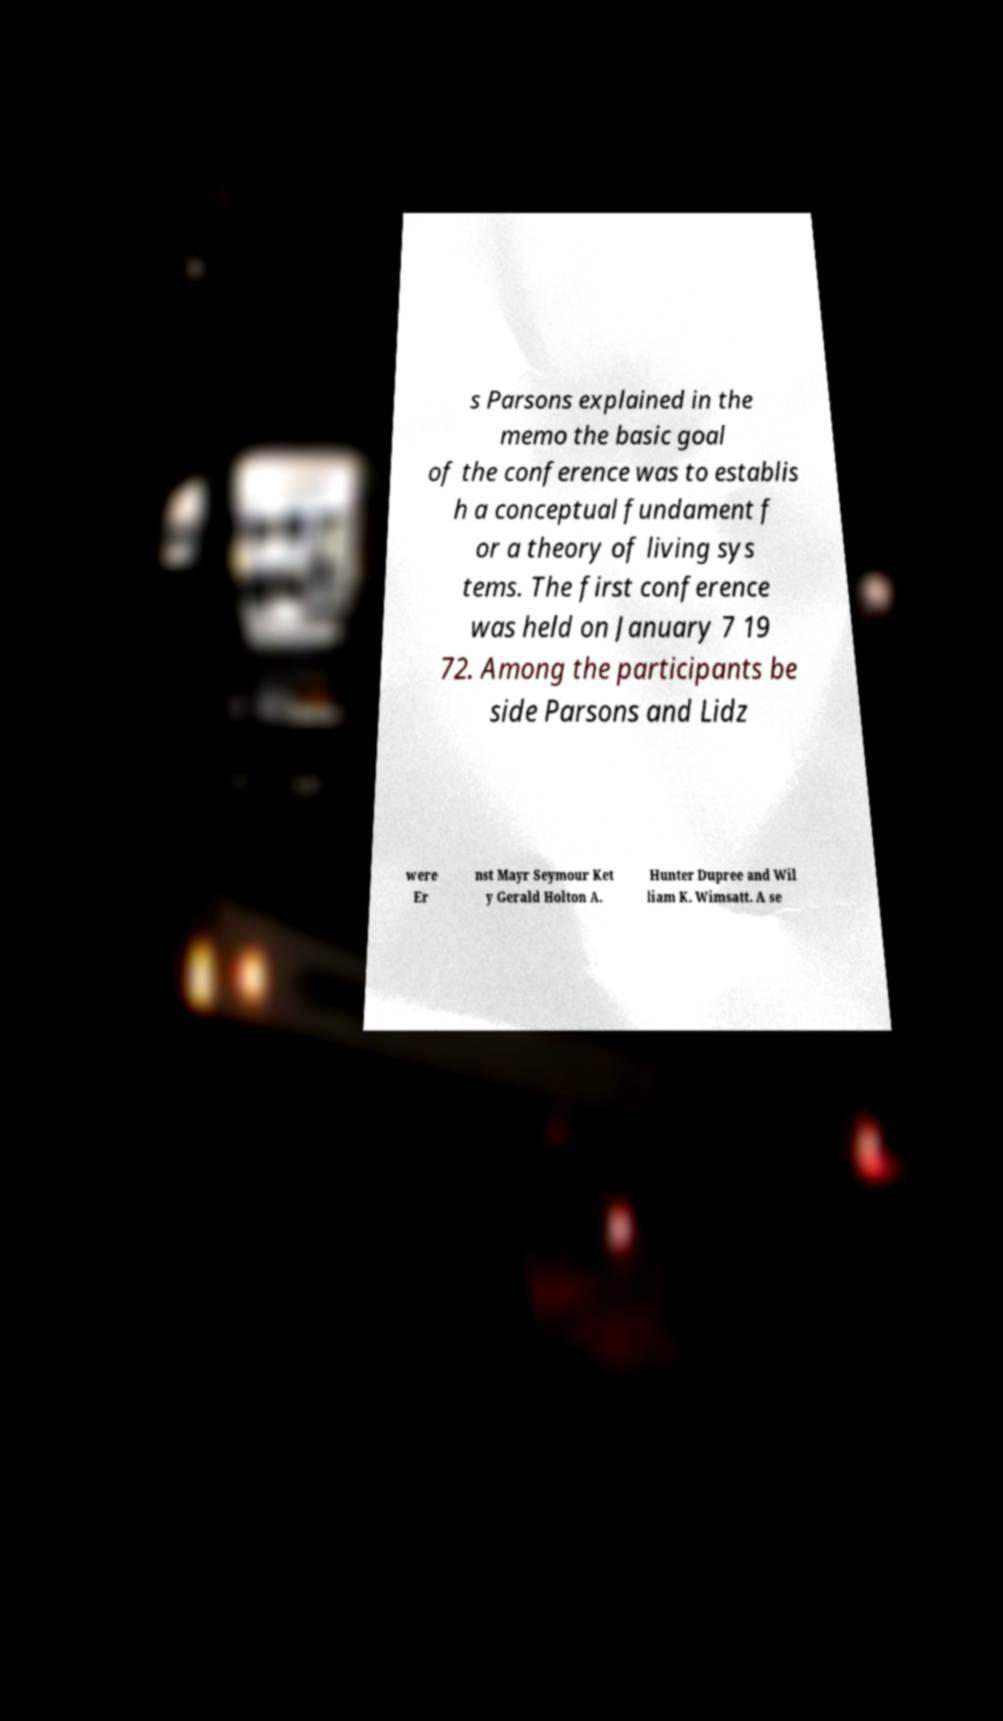Please identify and transcribe the text found in this image. s Parsons explained in the memo the basic goal of the conference was to establis h a conceptual fundament f or a theory of living sys tems. The first conference was held on January 7 19 72. Among the participants be side Parsons and Lidz were Er nst Mayr Seymour Ket y Gerald Holton A. Hunter Dupree and Wil liam K. Wimsatt. A se 